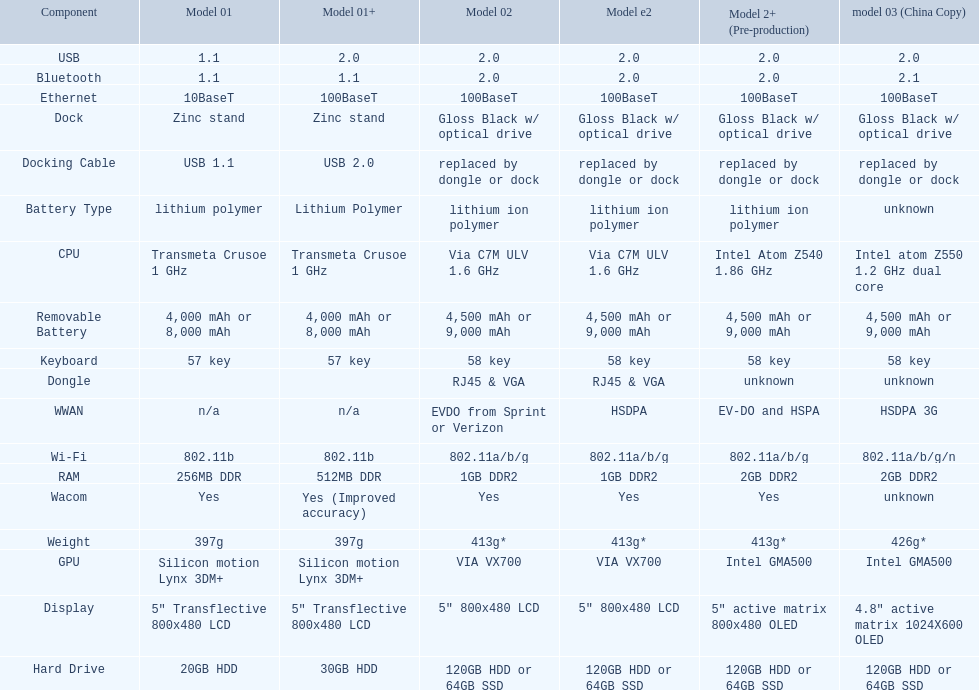Which model provides a larger hard drive: model 01 or model 02? Model 02. 